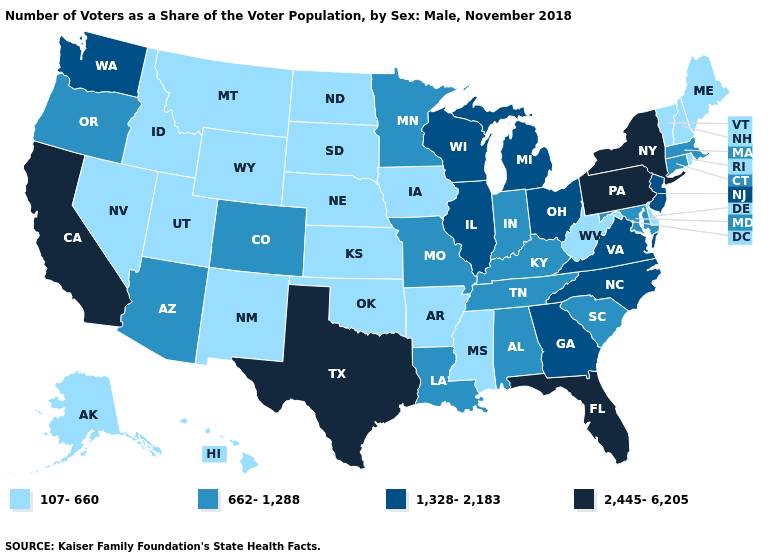Name the states that have a value in the range 107-660?
Keep it brief. Alaska, Arkansas, Delaware, Hawaii, Idaho, Iowa, Kansas, Maine, Mississippi, Montana, Nebraska, Nevada, New Hampshire, New Mexico, North Dakota, Oklahoma, Rhode Island, South Dakota, Utah, Vermont, West Virginia, Wyoming. Among the states that border South Dakota , does Wyoming have the highest value?
Write a very short answer. No. Does the map have missing data?
Keep it brief. No. Does Maryland have the highest value in the USA?
Quick response, please. No. What is the value of Kentucky?
Quick response, please. 662-1,288. What is the value of Washington?
Write a very short answer. 1,328-2,183. What is the value of Montana?
Keep it brief. 107-660. Among the states that border South Carolina , which have the lowest value?
Keep it brief. Georgia, North Carolina. What is the highest value in the USA?
Keep it brief. 2,445-6,205. Which states have the lowest value in the USA?
Give a very brief answer. Alaska, Arkansas, Delaware, Hawaii, Idaho, Iowa, Kansas, Maine, Mississippi, Montana, Nebraska, Nevada, New Hampshire, New Mexico, North Dakota, Oklahoma, Rhode Island, South Dakota, Utah, Vermont, West Virginia, Wyoming. What is the value of New Mexico?
Keep it brief. 107-660. What is the value of South Carolina?
Quick response, please. 662-1,288. What is the lowest value in the USA?
Give a very brief answer. 107-660. Which states have the lowest value in the South?
Be succinct. Arkansas, Delaware, Mississippi, Oklahoma, West Virginia. Does the map have missing data?
Give a very brief answer. No. 